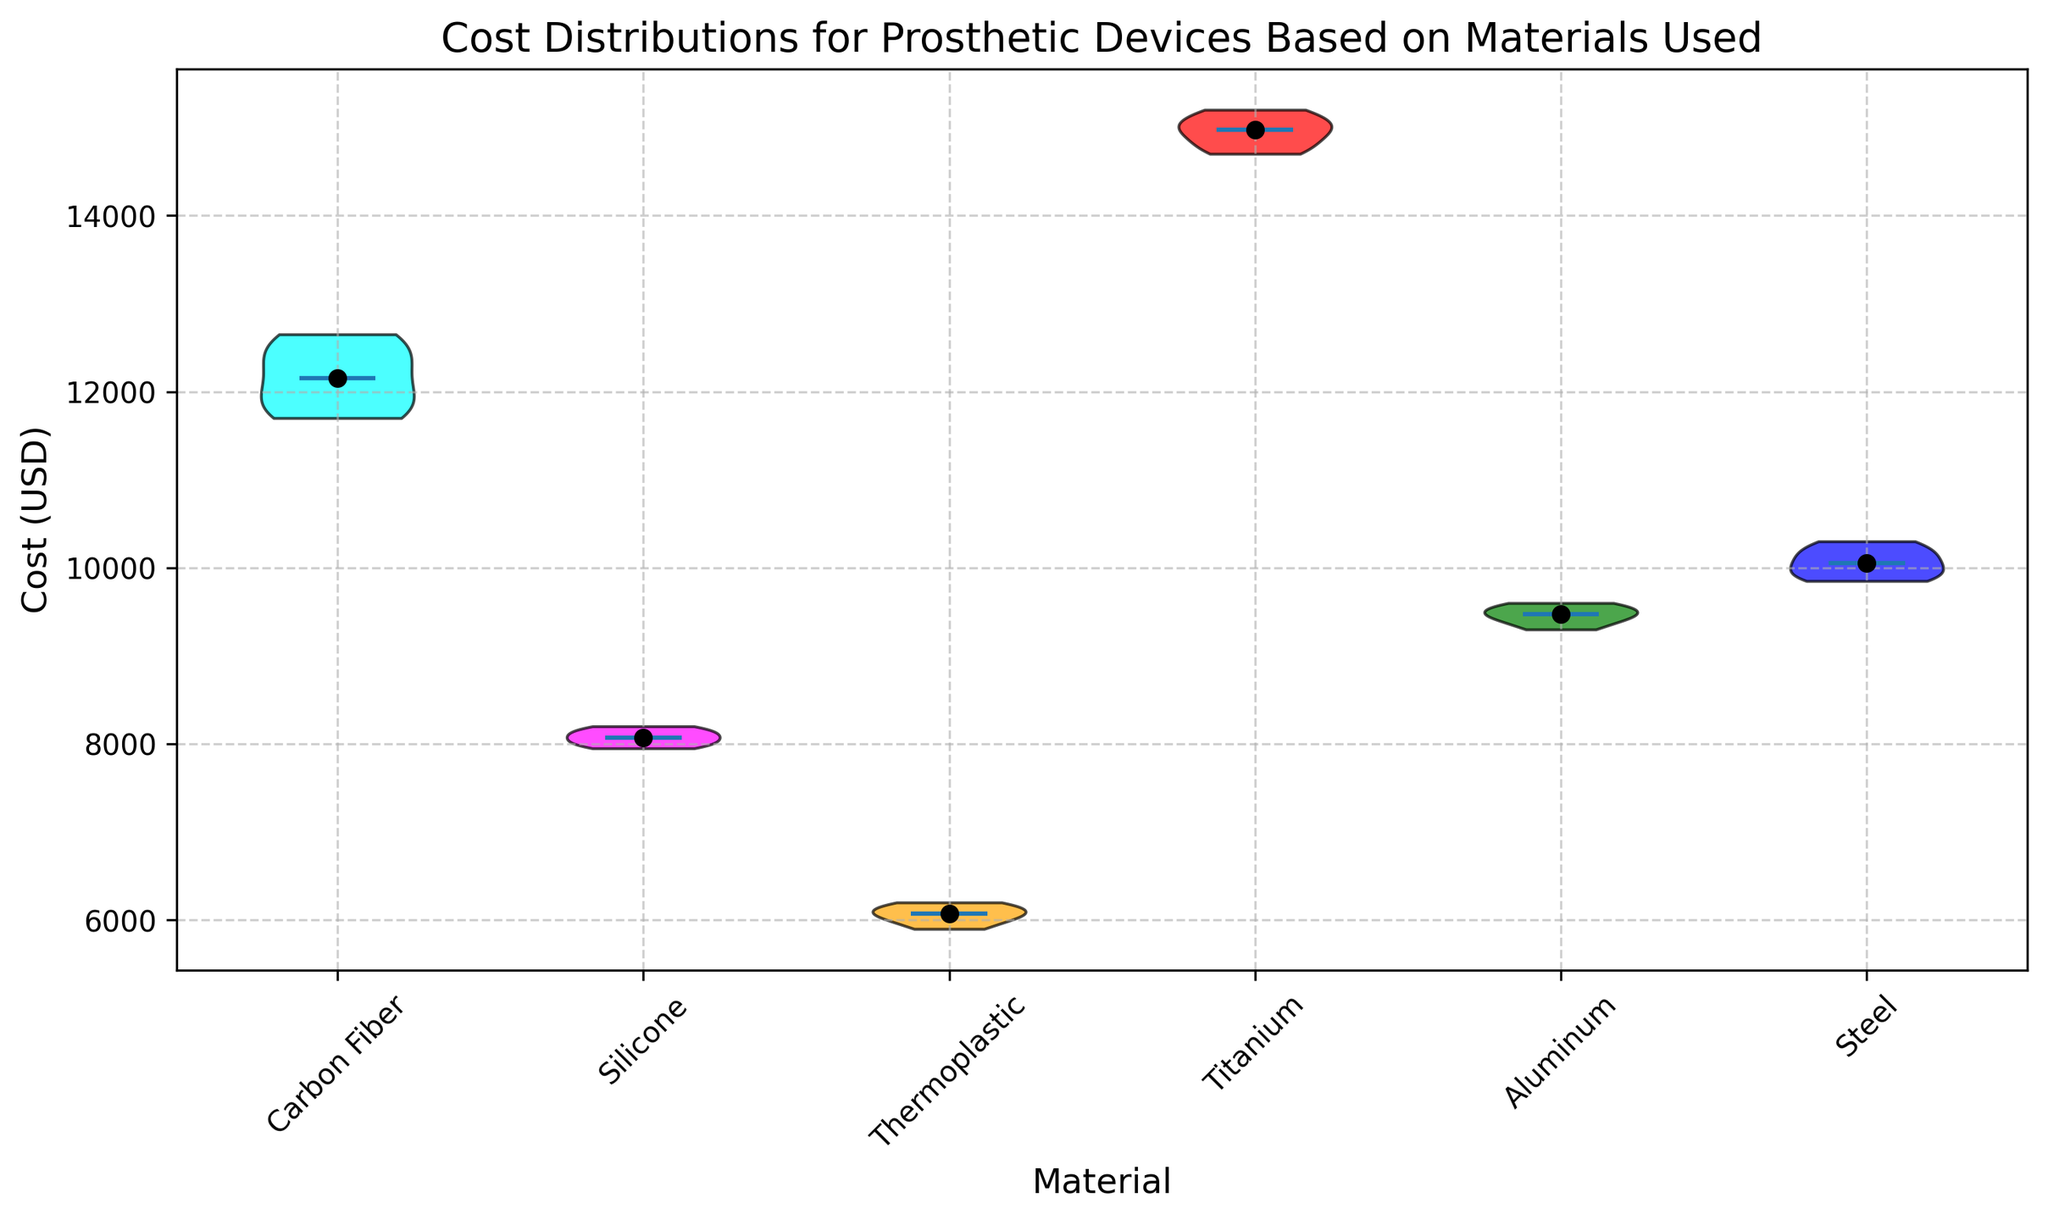Which material has the highest median cost? The median line (black dot) in the violin plot shows Titanium has the highest median cost.
Answer: Titanium What's the range of costs for Steel prosthetic devices? The extremity of the violin shape indicates the range. For Steel, the lowest point is \( \approx 9850 \) and the highest point is \( \approx 10300 \). The range is \( 10300 - 9850 = 450 \).
Answer: 450 Which material has the widest distribution of costs? The width of the violin plot represents distribution. Carbon Fiber has the widest distribution compared to the other materials.
Answer: Carbon Fiber Compare the median costs of Carbon Fiber and Aluminum. Which is higher? The black dot representation shows that the median cost of Carbon Fiber is higher than Aluminum.
Answer: Carbon Fiber Which materials have their median costs below \( \text{(median of Carbon Fiber)}? \) The median for Carbon Fiber can be estimated and compared visually. All materials except Titanium are below the median of Carbon Fiber.
Answer: Silicone, Thermoplastic, Aluminum, Steel Among Silicone, Aluminum, and Steel, which has the narrowest cost distribution? The narrowest portion of the violin plot indicates the distribution. Silicone has the narrowest distribution among the three.
Answer: Silicone Calculate the average of the median costs of Silicone and Thermoplastic. First, find the medians of both (midpoint of the black dots): Silicone (\(\approx 8100\)), Thermoplastic (\(\approx 6050\)). The average is \((8100 + 6050)/2 = 7075\).
Answer: 7075 If you combine the costs of Aluminum and Titanium, what is the combined range? The ranges are: Aluminum (\(\approx 9300\) to \(\approx 9600\)), Titanium (\(\approx 14700\) to  \( \approx 15200 \)). The combined range is the difference between the highest max and lowest min: \(15200 - 9300 = 5900\).
Answer: 5900 What's the interquartile range (IQR) for Carbon Fiber costs, if visible? Typically, IQR can't be directly inferred just from a violin plot, as it needs quartile data. This is noted to explain limitations.
Answer: Not directly inferable 